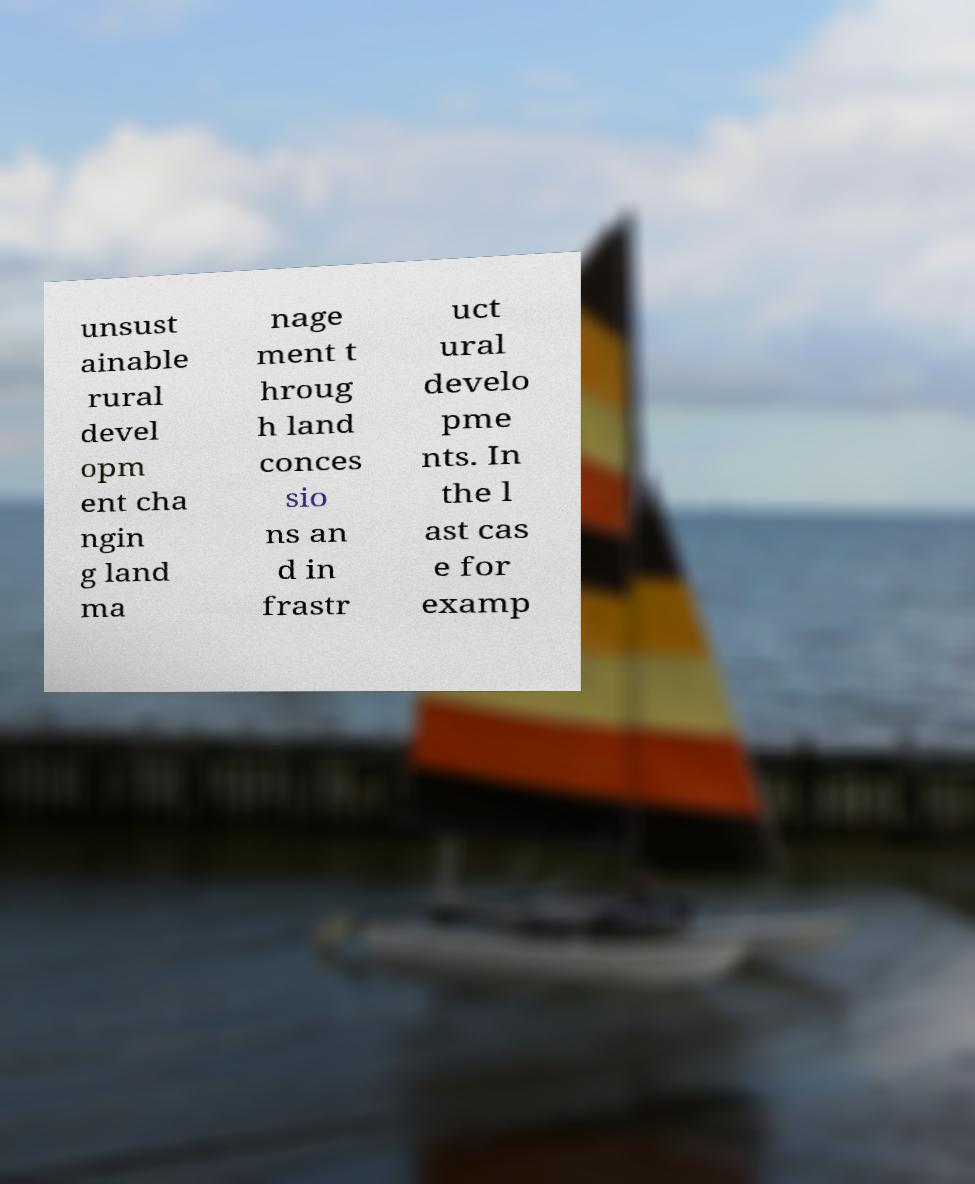For documentation purposes, I need the text within this image transcribed. Could you provide that? unsust ainable rural devel opm ent cha ngin g land ma nage ment t hroug h land conces sio ns an d in frastr uct ural develo pme nts. In the l ast cas e for examp 